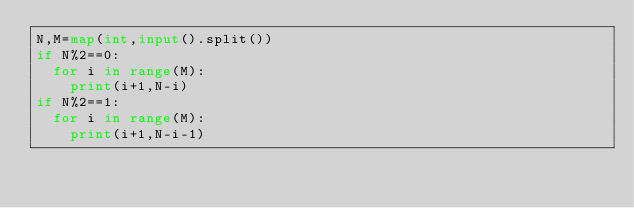<code> <loc_0><loc_0><loc_500><loc_500><_Python_>N,M=map(int,input().split())
if N%2==0:
  for i in range(M):
    print(i+1,N-i)
if N%2==1:
  for i in range(M):
    print(i+1,N-i-1)

</code> 